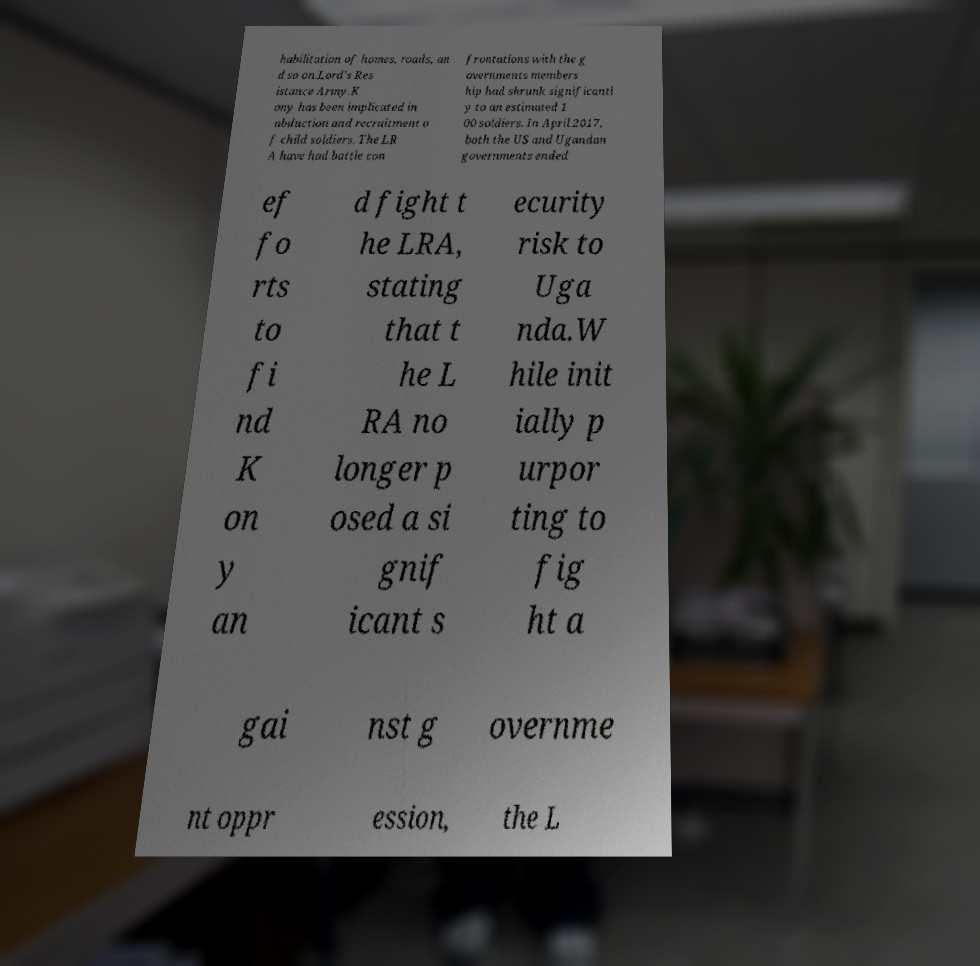There's text embedded in this image that I need extracted. Can you transcribe it verbatim? habilitation of homes, roads, an d so on.Lord's Res istance Army.K ony has been implicated in abduction and recruitment o f child soldiers. The LR A have had battle con frontations with the g overnments members hip had shrunk significantl y to an estimated 1 00 soldiers. In April 2017, both the US and Ugandan governments ended ef fo rts to fi nd K on y an d fight t he LRA, stating that t he L RA no longer p osed a si gnif icant s ecurity risk to Uga nda.W hile init ially p urpor ting to fig ht a gai nst g overnme nt oppr ession, the L 